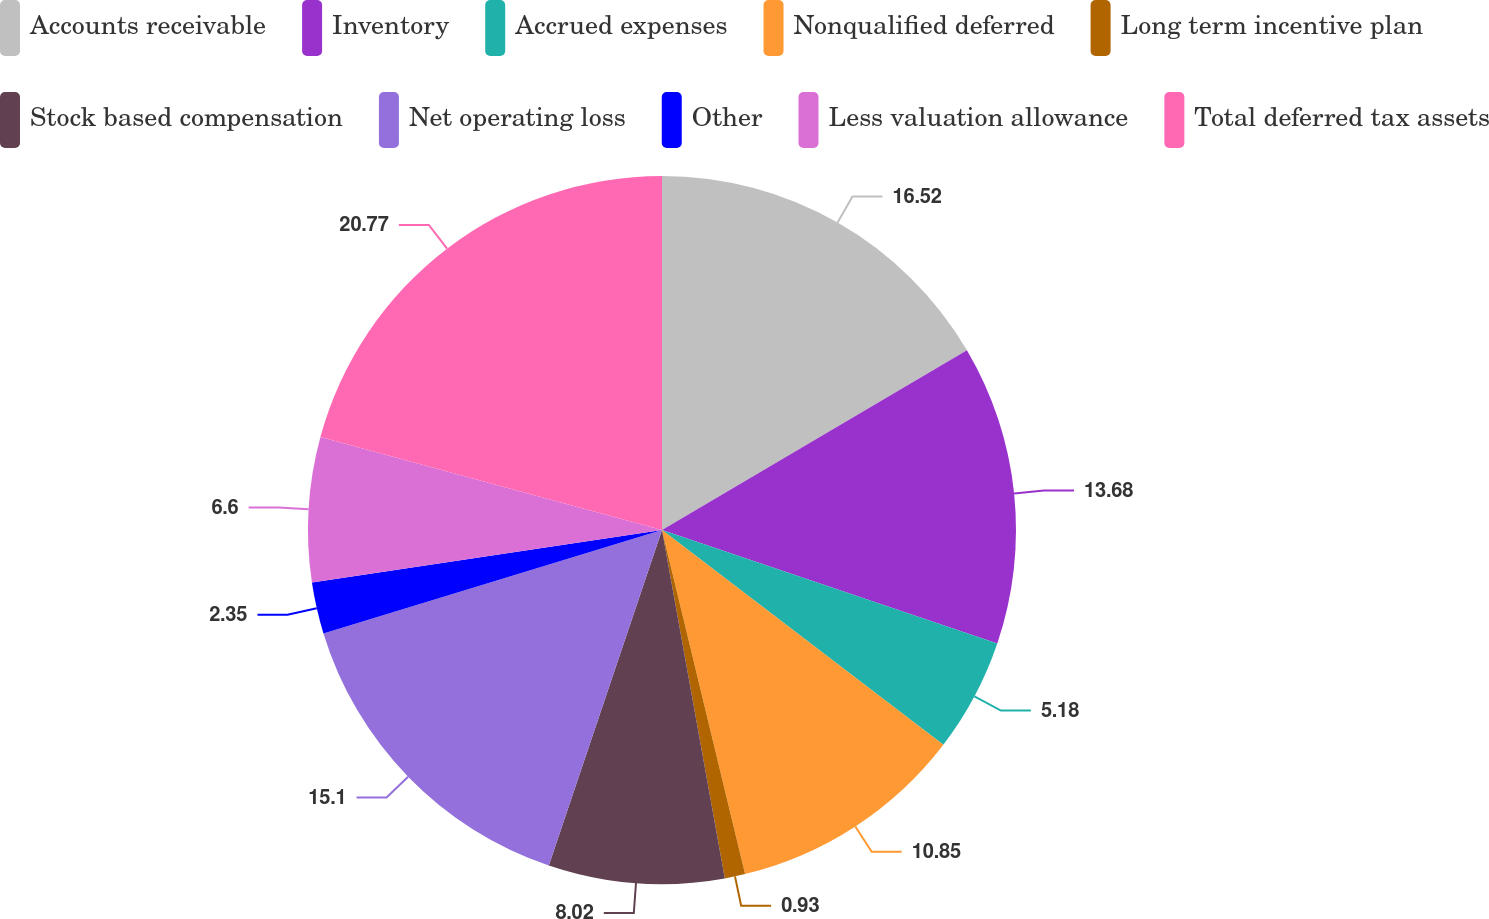Convert chart. <chart><loc_0><loc_0><loc_500><loc_500><pie_chart><fcel>Accounts receivable<fcel>Inventory<fcel>Accrued expenses<fcel>Nonqualified deferred<fcel>Long term incentive plan<fcel>Stock based compensation<fcel>Net operating loss<fcel>Other<fcel>Less valuation allowance<fcel>Total deferred tax assets<nl><fcel>16.52%<fcel>13.68%<fcel>5.18%<fcel>10.85%<fcel>0.93%<fcel>8.02%<fcel>15.1%<fcel>2.35%<fcel>6.6%<fcel>20.77%<nl></chart> 